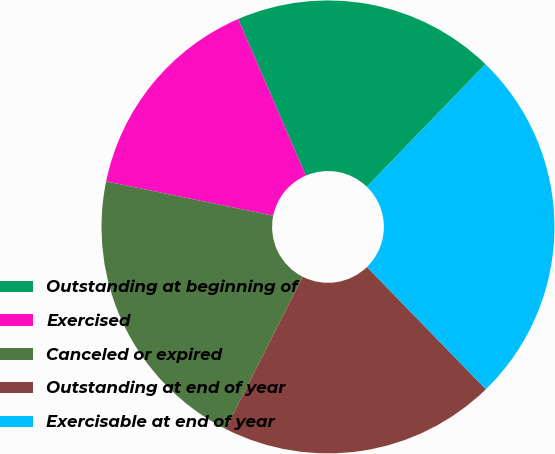Convert chart. <chart><loc_0><loc_0><loc_500><loc_500><pie_chart><fcel>Outstanding at beginning of<fcel>Exercised<fcel>Canceled or expired<fcel>Outstanding at end of year<fcel>Exercisable at end of year<nl><fcel>18.73%<fcel>15.29%<fcel>20.76%<fcel>19.74%<fcel>25.48%<nl></chart> 